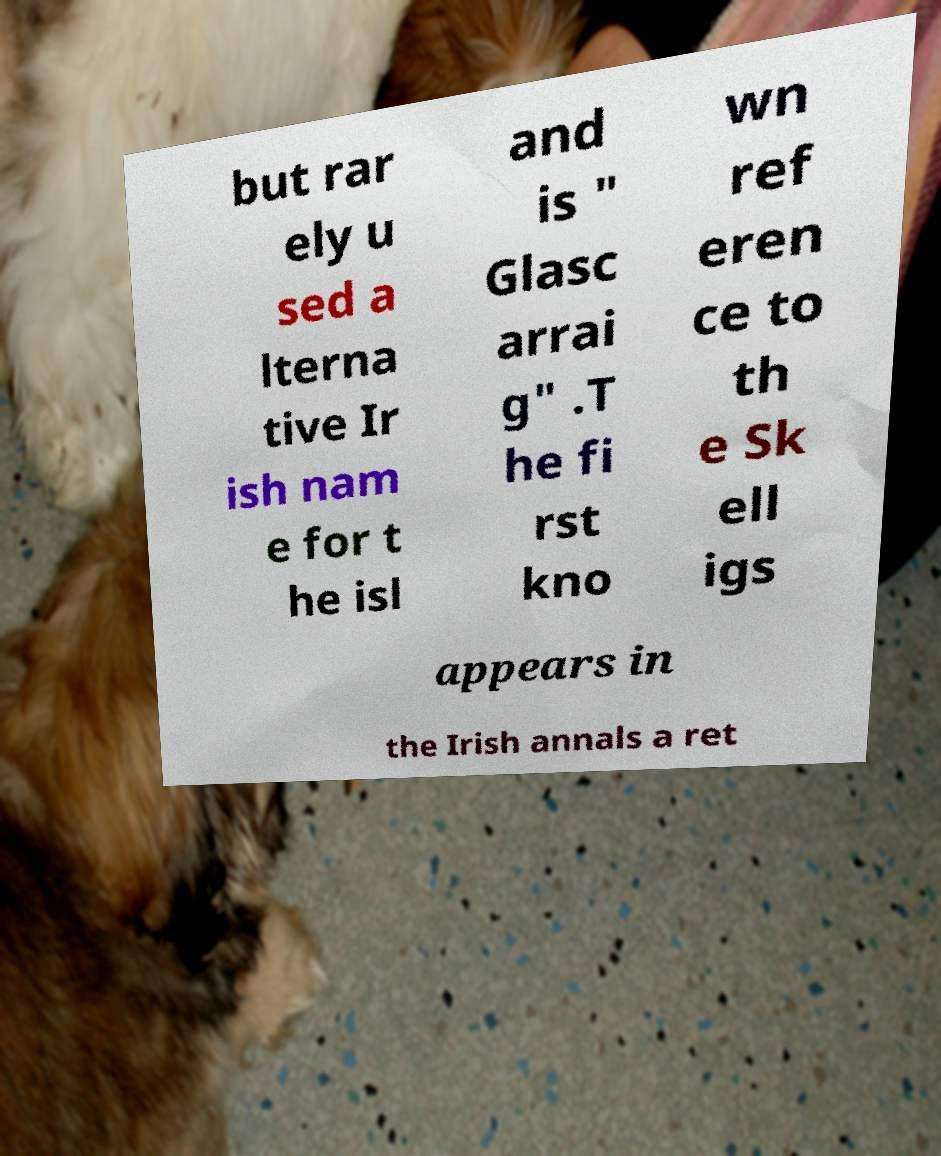Can you read and provide the text displayed in the image?This photo seems to have some interesting text. Can you extract and type it out for me? but rar ely u sed a lterna tive Ir ish nam e for t he isl and is " Glasc arrai g" .T he fi rst kno wn ref eren ce to th e Sk ell igs appears in the Irish annals a ret 